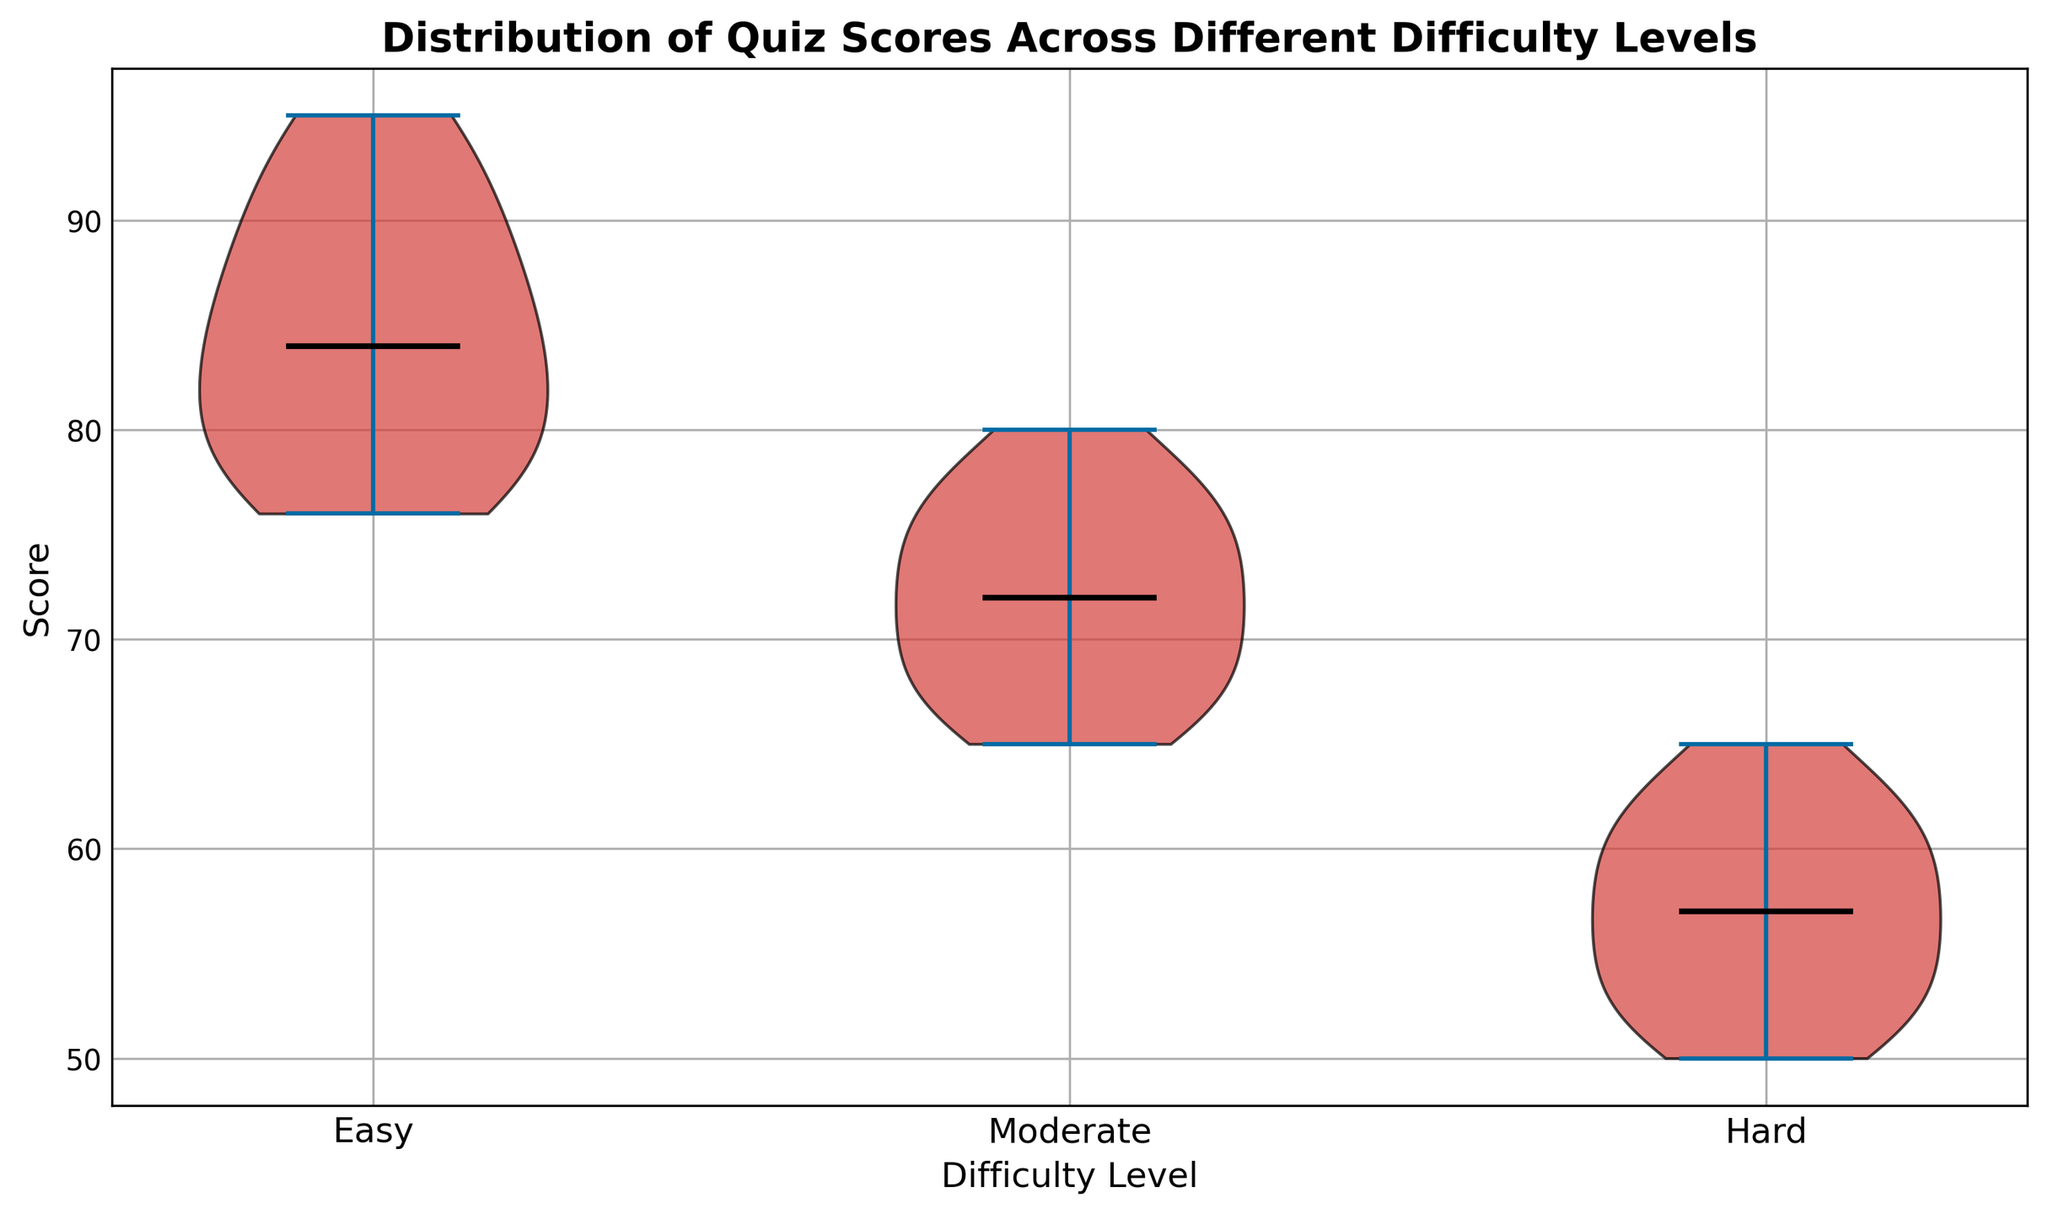Which difficulty level has the highest median quiz score? The plot shows the median quiz scores for different difficulty levels as black lines. Identify the difficulty level with the highest position of the black line.
Answer: Easy How does the spread of scores for the Easy level compare to the Hard level? Observe the width of the violins for Easy and Hard. The wider the violin, the more spread out the scores are.
Answer: Easier level has a narrower spread, and Hard level has a wider spread What is the trend of median quiz scores as difficulty level increases? Analyze the position of the median lines (black lines) across the difficulty levels. See how they move as you go from Easy to Moderate to Hard.
Answer: The medians decrease as the difficulty increases Are the quiz scores for the Moderate difficulty level more varied than the Easy level? Compare the width of the violins for Moderate and Easy levels. The violin with a wider spread indicates more variability.
Answer: Yes What does the central black line in each violin plot represent? In a violin plot, the central black line represents the median of the scores for that difficulty level.
Answer: Median Which difficulty level has the smallest median score? Look for the difficulty level where the median line (black line) is lowest on the vertical axis.
Answer: Hard Is the distribution of quiz scores skewed for the Easy difficulty level? Assess the shape of the violin plot for Easy. If one tail is longer or if it is asymmetric, it might indicate skewness.
Answer: Slightly skewed to the lower end How do the interquartile ranges of Easy and Moderate difficulty levels compare? The breadth within the thickest part of each violin indicates the interquartile range. Compare the thickness of the central area of the two violins.
Answer: Easy has a narrower interquartile range than Moderate What visual attribute indicates the median in the violin plot? Identify which part of the violin plot uses a specific visual attribute to show the median.
Answer: Black line By comparing the heights of the violins, which difficulty level has quiz scores consistently above 50? Determine the lowest point of the violins' vertical spread to see which one stays above 50.
Answer: Easy and Moderate 